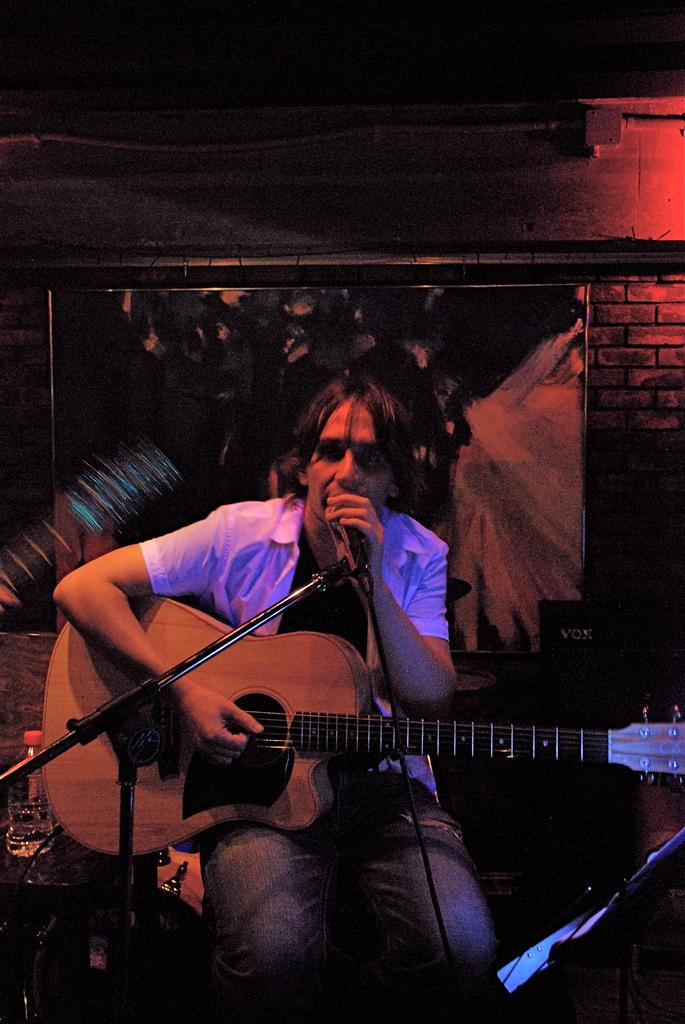What is the main subject of the image? There is a person in the image. What is the setting of the image? The person is in a dark room. What is the person holding in the image? The person is holding a microphone and a guitar. What can be seen on the wall in the image? There is a wall poster on a brick wall in the image. What type of connections are visible in the image? There are wire line connections in the image. What day of the week is depicted in the image? There is no indication of the day of the week in the image. 